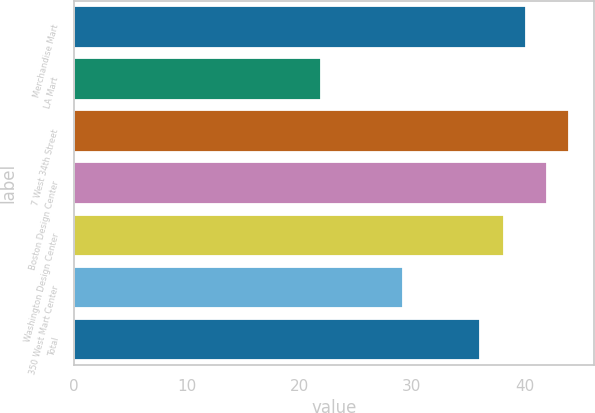Convert chart. <chart><loc_0><loc_0><loc_500><loc_500><bar_chart><fcel>Merchandise Mart<fcel>LA Mart<fcel>7 West 34th Street<fcel>Boston Design Center<fcel>Washington Design Center<fcel>350 West Mart Center<fcel>Total<nl><fcel>40.11<fcel>21.95<fcel>43.93<fcel>42.02<fcel>38.2<fcel>29.18<fcel>36.03<nl></chart> 